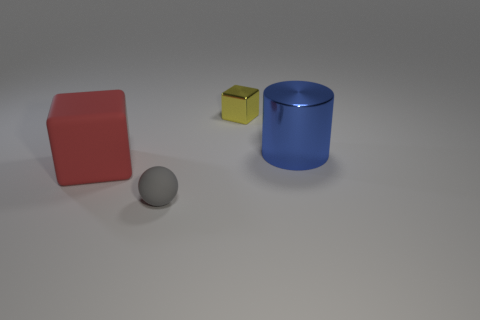Subtract all brown blocks. Subtract all gray balls. How many blocks are left? 2 Subtract all cyan cylinders. How many gray cubes are left? 0 Add 2 small things. How many large blues exist? 0 Subtract all yellow things. Subtract all large shiny cylinders. How many objects are left? 2 Add 3 tiny gray spheres. How many tiny gray spheres are left? 4 Add 1 small red shiny things. How many small red shiny things exist? 1 Add 1 large blue shiny spheres. How many objects exist? 5 Subtract all yellow cubes. How many cubes are left? 1 Subtract 0 brown blocks. How many objects are left? 4 Subtract all spheres. How many objects are left? 3 